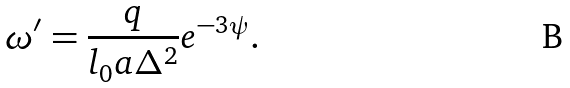<formula> <loc_0><loc_0><loc_500><loc_500>\omega ^ { \prime } = \frac { q } { l _ { 0 } a \Delta ^ { 2 } } e ^ { - 3 \psi } .</formula> 